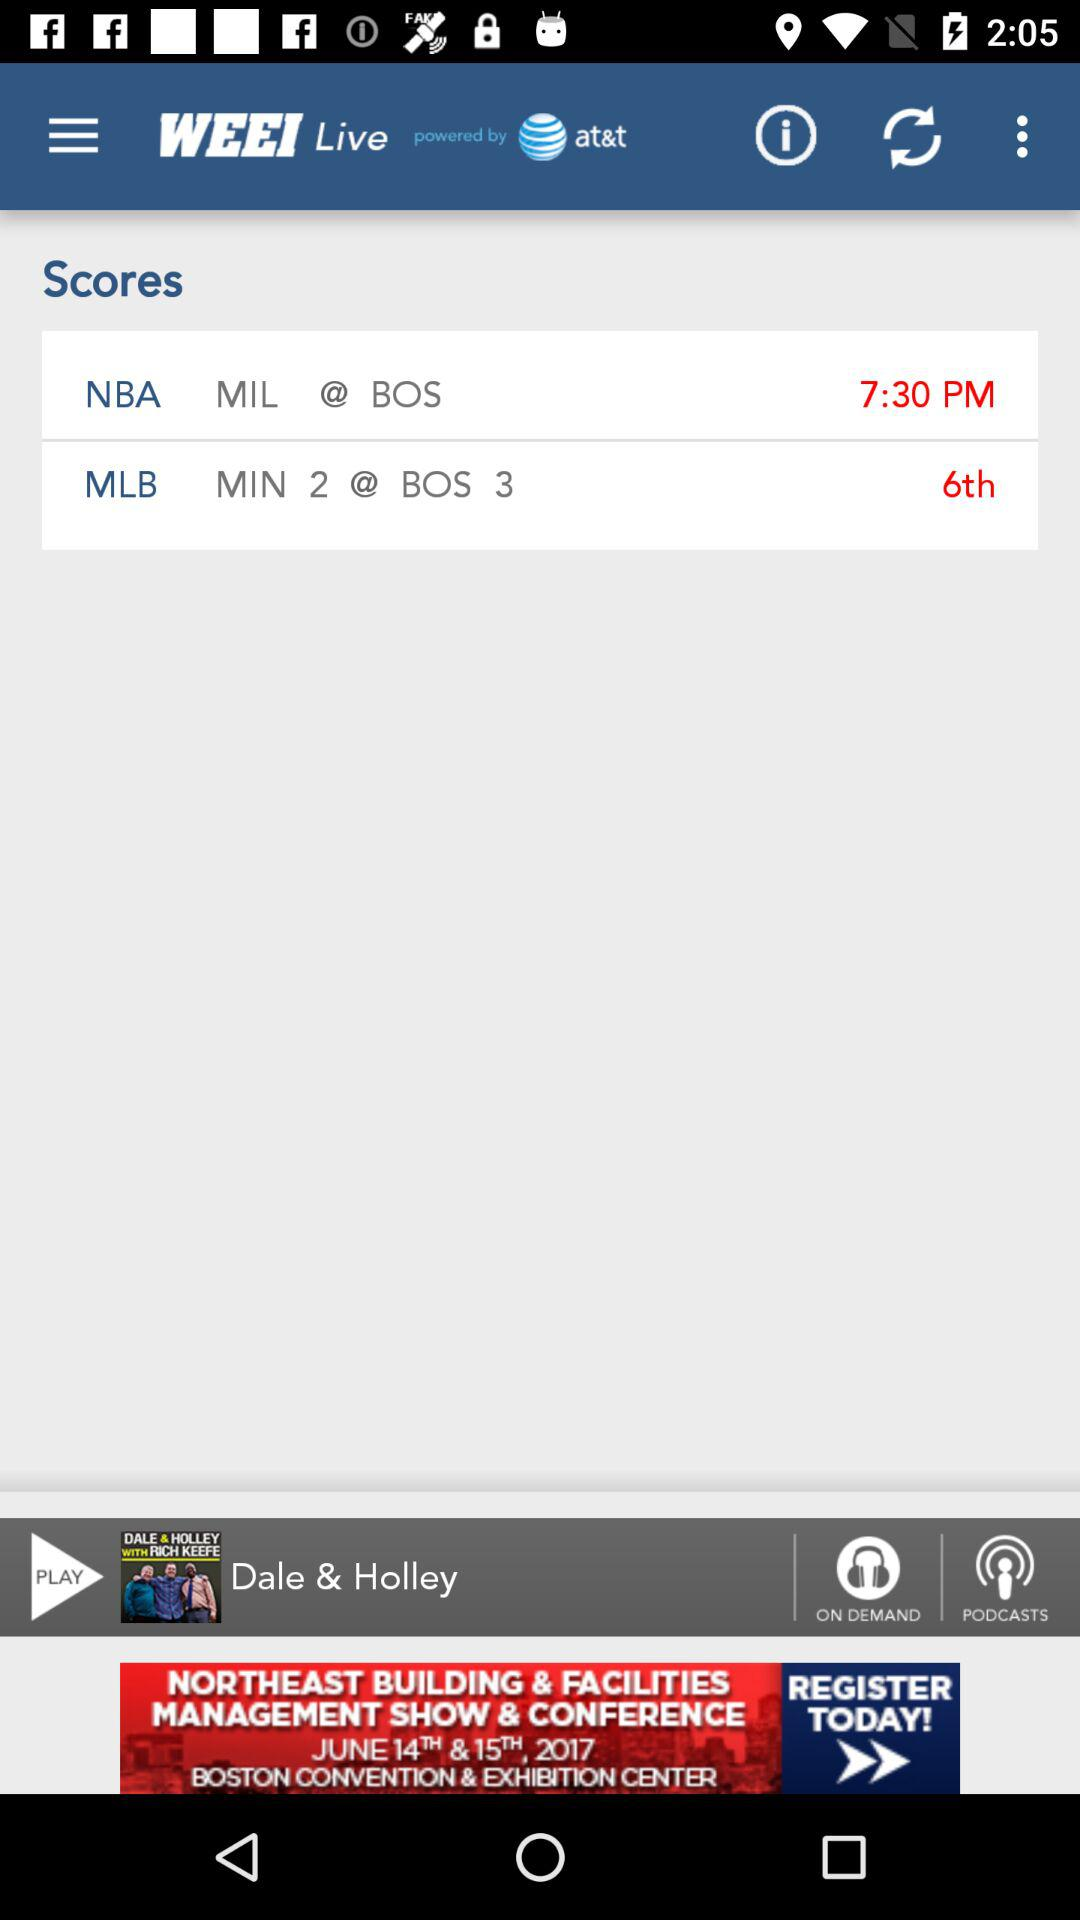What is the score between MIN and BOS in MLB? The scores between MIN and BOS in MLB are 2 and 3, respectively. 